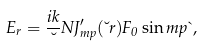<formula> <loc_0><loc_0><loc_500><loc_500>E _ { r } = \frac { i k } { \lambda } N J ^ { \prime } _ { m p } ( \lambda r ) F _ { 0 } \sin m p \theta ,</formula> 